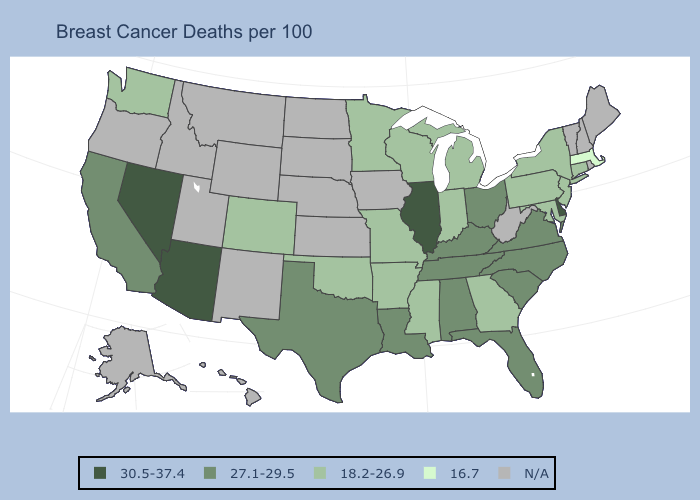Name the states that have a value in the range 18.2-26.9?
Write a very short answer. Arkansas, Colorado, Connecticut, Georgia, Indiana, Maryland, Michigan, Minnesota, Mississippi, Missouri, New Jersey, New York, Oklahoma, Pennsylvania, Washington, Wisconsin. Which states have the lowest value in the USA?
Be succinct. Massachusetts. Does Arizona have the lowest value in the West?
Keep it brief. No. Is the legend a continuous bar?
Answer briefly. No. Name the states that have a value in the range N/A?
Keep it brief. Alaska, Hawaii, Idaho, Iowa, Kansas, Maine, Montana, Nebraska, New Hampshire, New Mexico, North Dakota, Oregon, Rhode Island, South Dakota, Utah, Vermont, West Virginia, Wyoming. What is the lowest value in states that border South Carolina?
Short answer required. 18.2-26.9. Does the map have missing data?
Answer briefly. Yes. Name the states that have a value in the range 27.1-29.5?
Concise answer only. Alabama, California, Florida, Kentucky, Louisiana, North Carolina, Ohio, South Carolina, Tennessee, Texas, Virginia. What is the highest value in the South ?
Keep it brief. 30.5-37.4. What is the value of Alaska?
Short answer required. N/A. What is the highest value in states that border Virginia?
Quick response, please. 27.1-29.5. What is the value of Rhode Island?
Concise answer only. N/A. Which states have the lowest value in the West?
Write a very short answer. Colorado, Washington. 